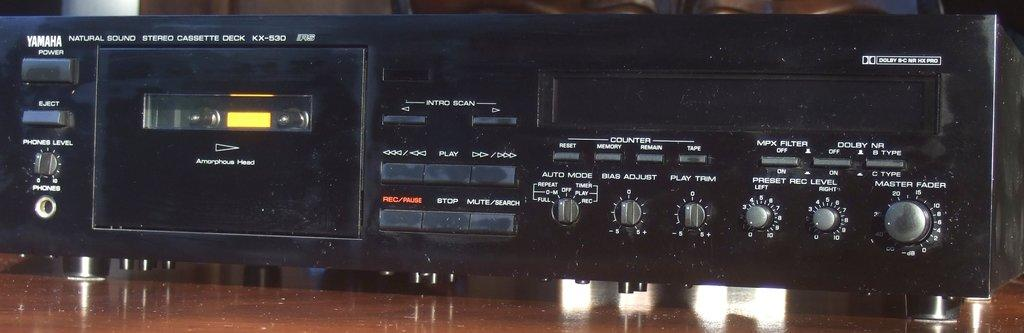<image>
Share a concise interpretation of the image provided. A black Yamaha stereo system sits on a wooden floor. 